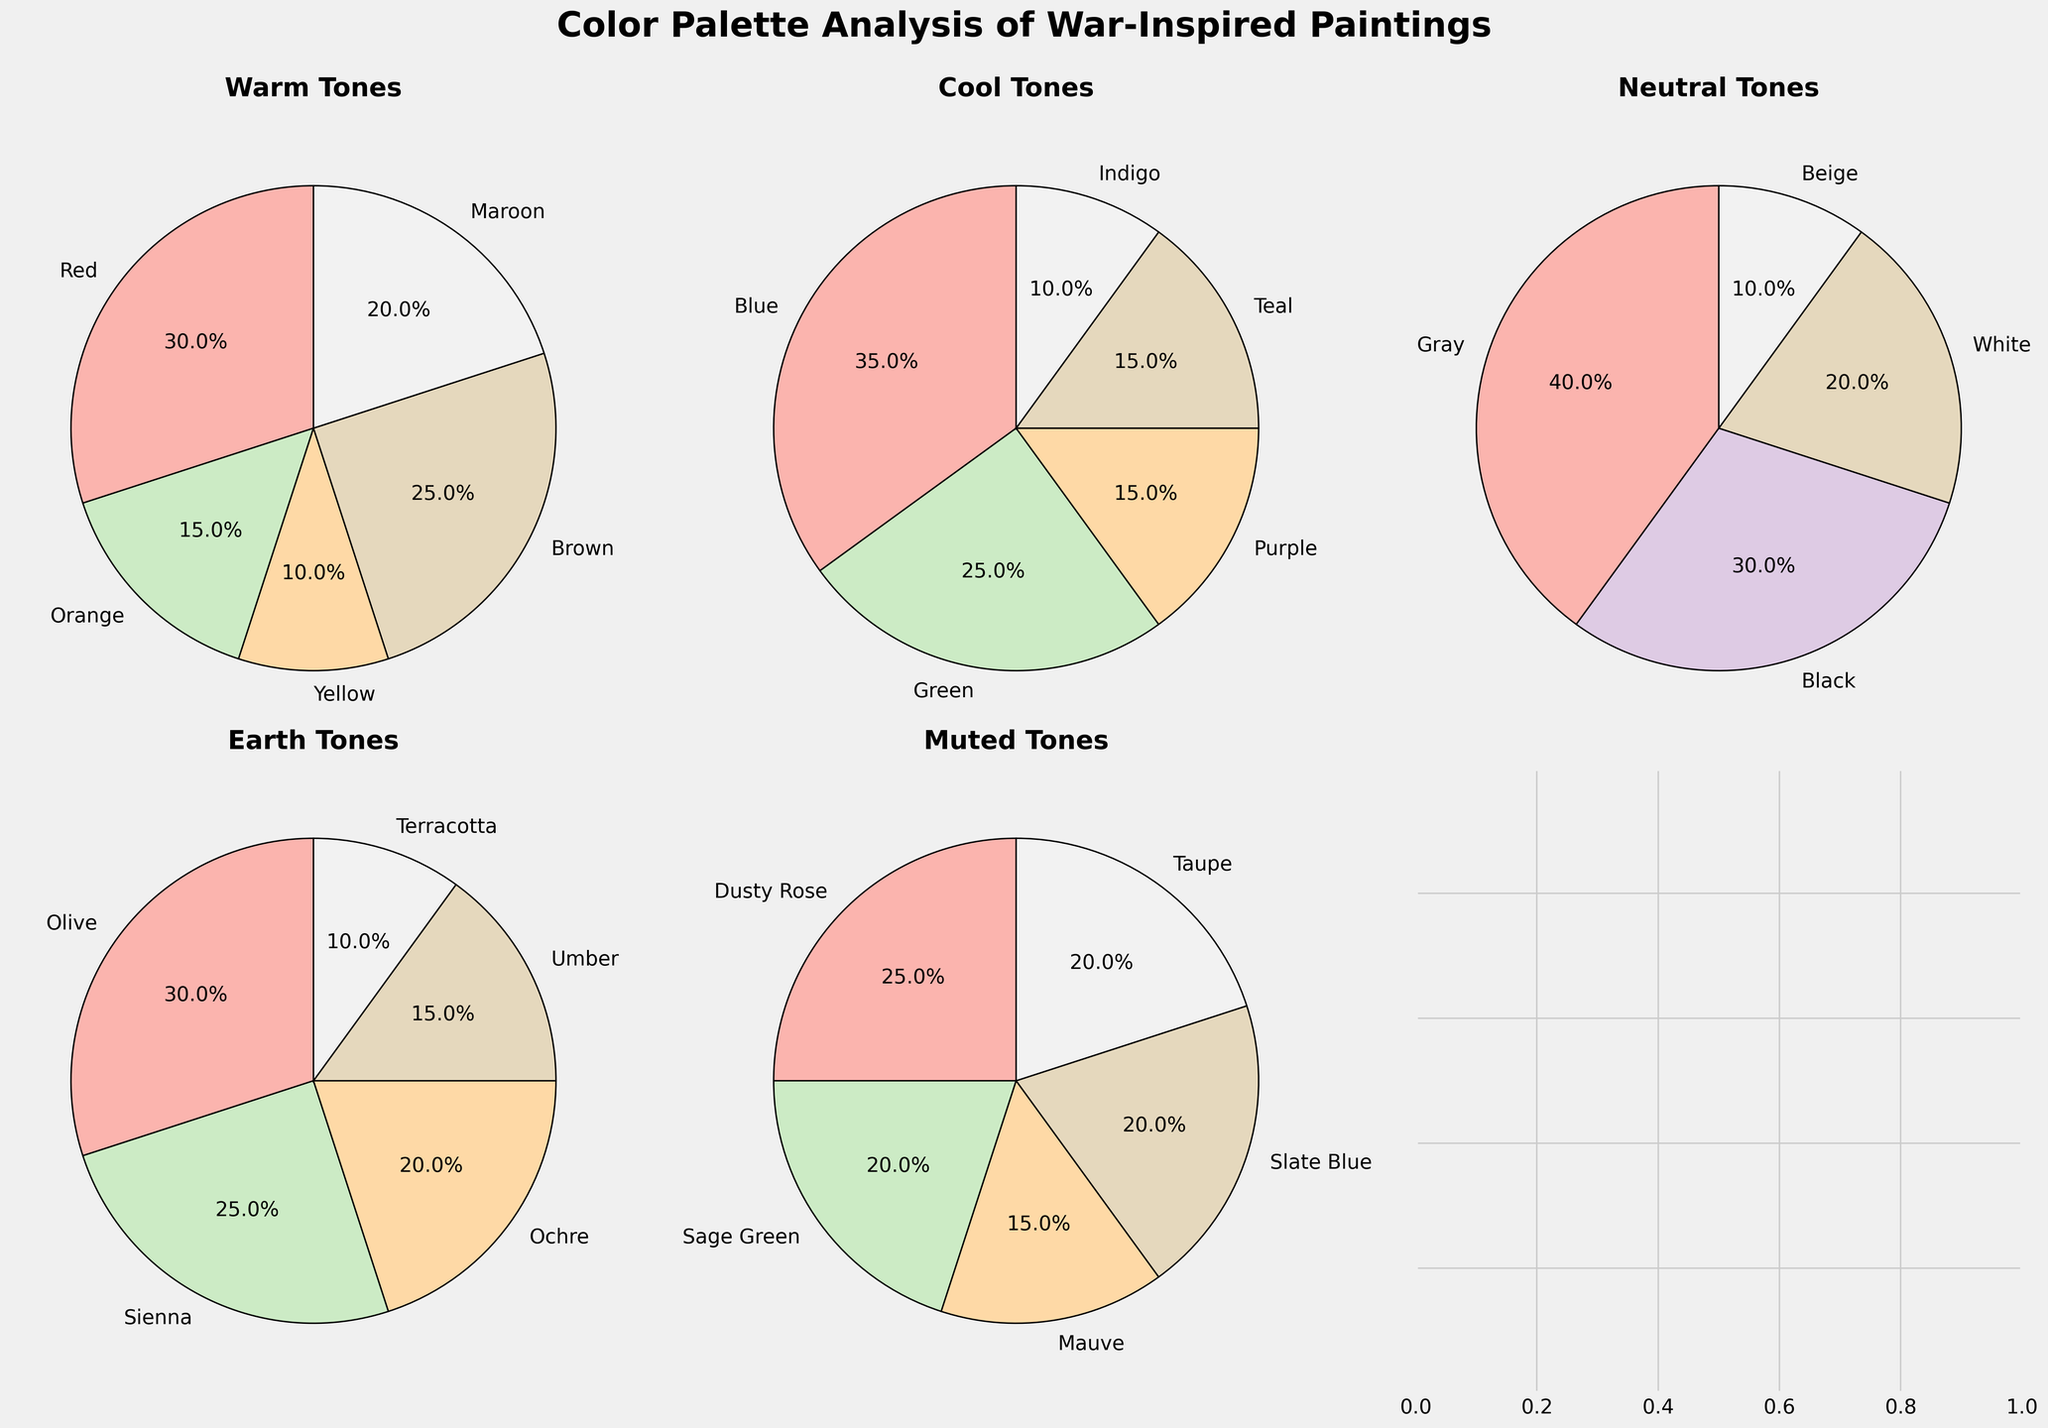What is the most dominant color in the Warm Tones hue family? The Warm Tones pie chart shows the slice representing Red as the largest, occupying 30%. Since 30% is the highest percentage within Warm Tones, it indicates Red is the dominant color.
Answer: Red Which hue family has the highest percentage of any single color, and what is that color? Reviewing the pie charts, Gray in the Neutral Tones hue family has the highest single percentage at 40%. This is more than any other single color percentage in other hue families.
Answer: Neutral Tones, Gray How does the combined percentage of Blue and Green in the Cool Tones compare to the percentage of Gray in the Neutral Tones? The Cool Tones pie chart shows Blue as 35% and Green as 25%. Summing these gives 35% + 25% = 60%. Meanwhile, Gray in the Neutral Tones is 40%. Hence, Blue and Green combined (60%) are greater than Gray (40%).
Answer: 60% vs 40% What is the total percentage of Maroon and Orange in the Warm Tones hue family? In the Warm Tones pie chart, Maroon is 20% and Orange is 15%. Adding these together, 20% + 15% = 35%.
Answer: 35% Which hue family has the smallest percentage allocated to the least dominant color, and what is that color and percentage? Examining the charts for the smallest slice, Earth Tones' pie chart shows Terracotta as 10%, which is the least across all hue families.
Answer: Earth Tones, Terracotta, 10% Compare the percentage of Sienna in the Earth Tones to the combined percentage of Taupe and Sage Green in the Muted Tones. The Earth Tones pie chart shows Sienna at 25%. The Muted Tones chart has Taupe at 20% and Sage Green at 20%. Summing for Muted Tones, 20% + 20% = 40%. Therefore, Sienna at 25% is less than the combined 40% of Taupe and Sage Green.
Answer: 25% vs 40% In which hue family does the color with the smallest percentage still have a higher percentage than Maroon in the Warm Tones? Maroon in Warm Tones is 20%. The smallest percentages in other hue families are 15% for Cool Tones (Indigo), Earth Tones (Terracotta), and Muted Tones (Mauve). All these are lower than 20%. Hence, there is no such hue family.
Answer: None Consider the Neutral Tones. What is the difference in percentage between the most prevalent color and the least prevalent color? The Neutral Tones pie chart shows Gray at 40% (most prevalent) and Beige at 10% (least prevalent). The difference is 40% - 10% = 30%.
Answer: 30% What is the visual difference between the Cool Tones chart and the Muted Tones chart regarding the most dominant color? In the Cool Tones chart, Blue is the most dominant occupation 35%. In the Muted Tones chart, Dusty Rose is the most dominant with 25%. Therefore, Blue at 35% exceeds Dusty Rose at 25% visually by 10%.
Answer: Blue at 35% vs Dusty Rose at 25% Is the percentage of Black in the Neutral Tones higher than the combined percentage of Yellow and Orange in the Warm Tones? Black in Neutral Tones is at 30%. Yellow (10%) and Orange (15%) in Warm Tones total 10% + 15% = 25%. Thus, 30% for Black is higher than the combined 25% for Yellow and Orange.
Answer: Yes, 30% vs 25% 